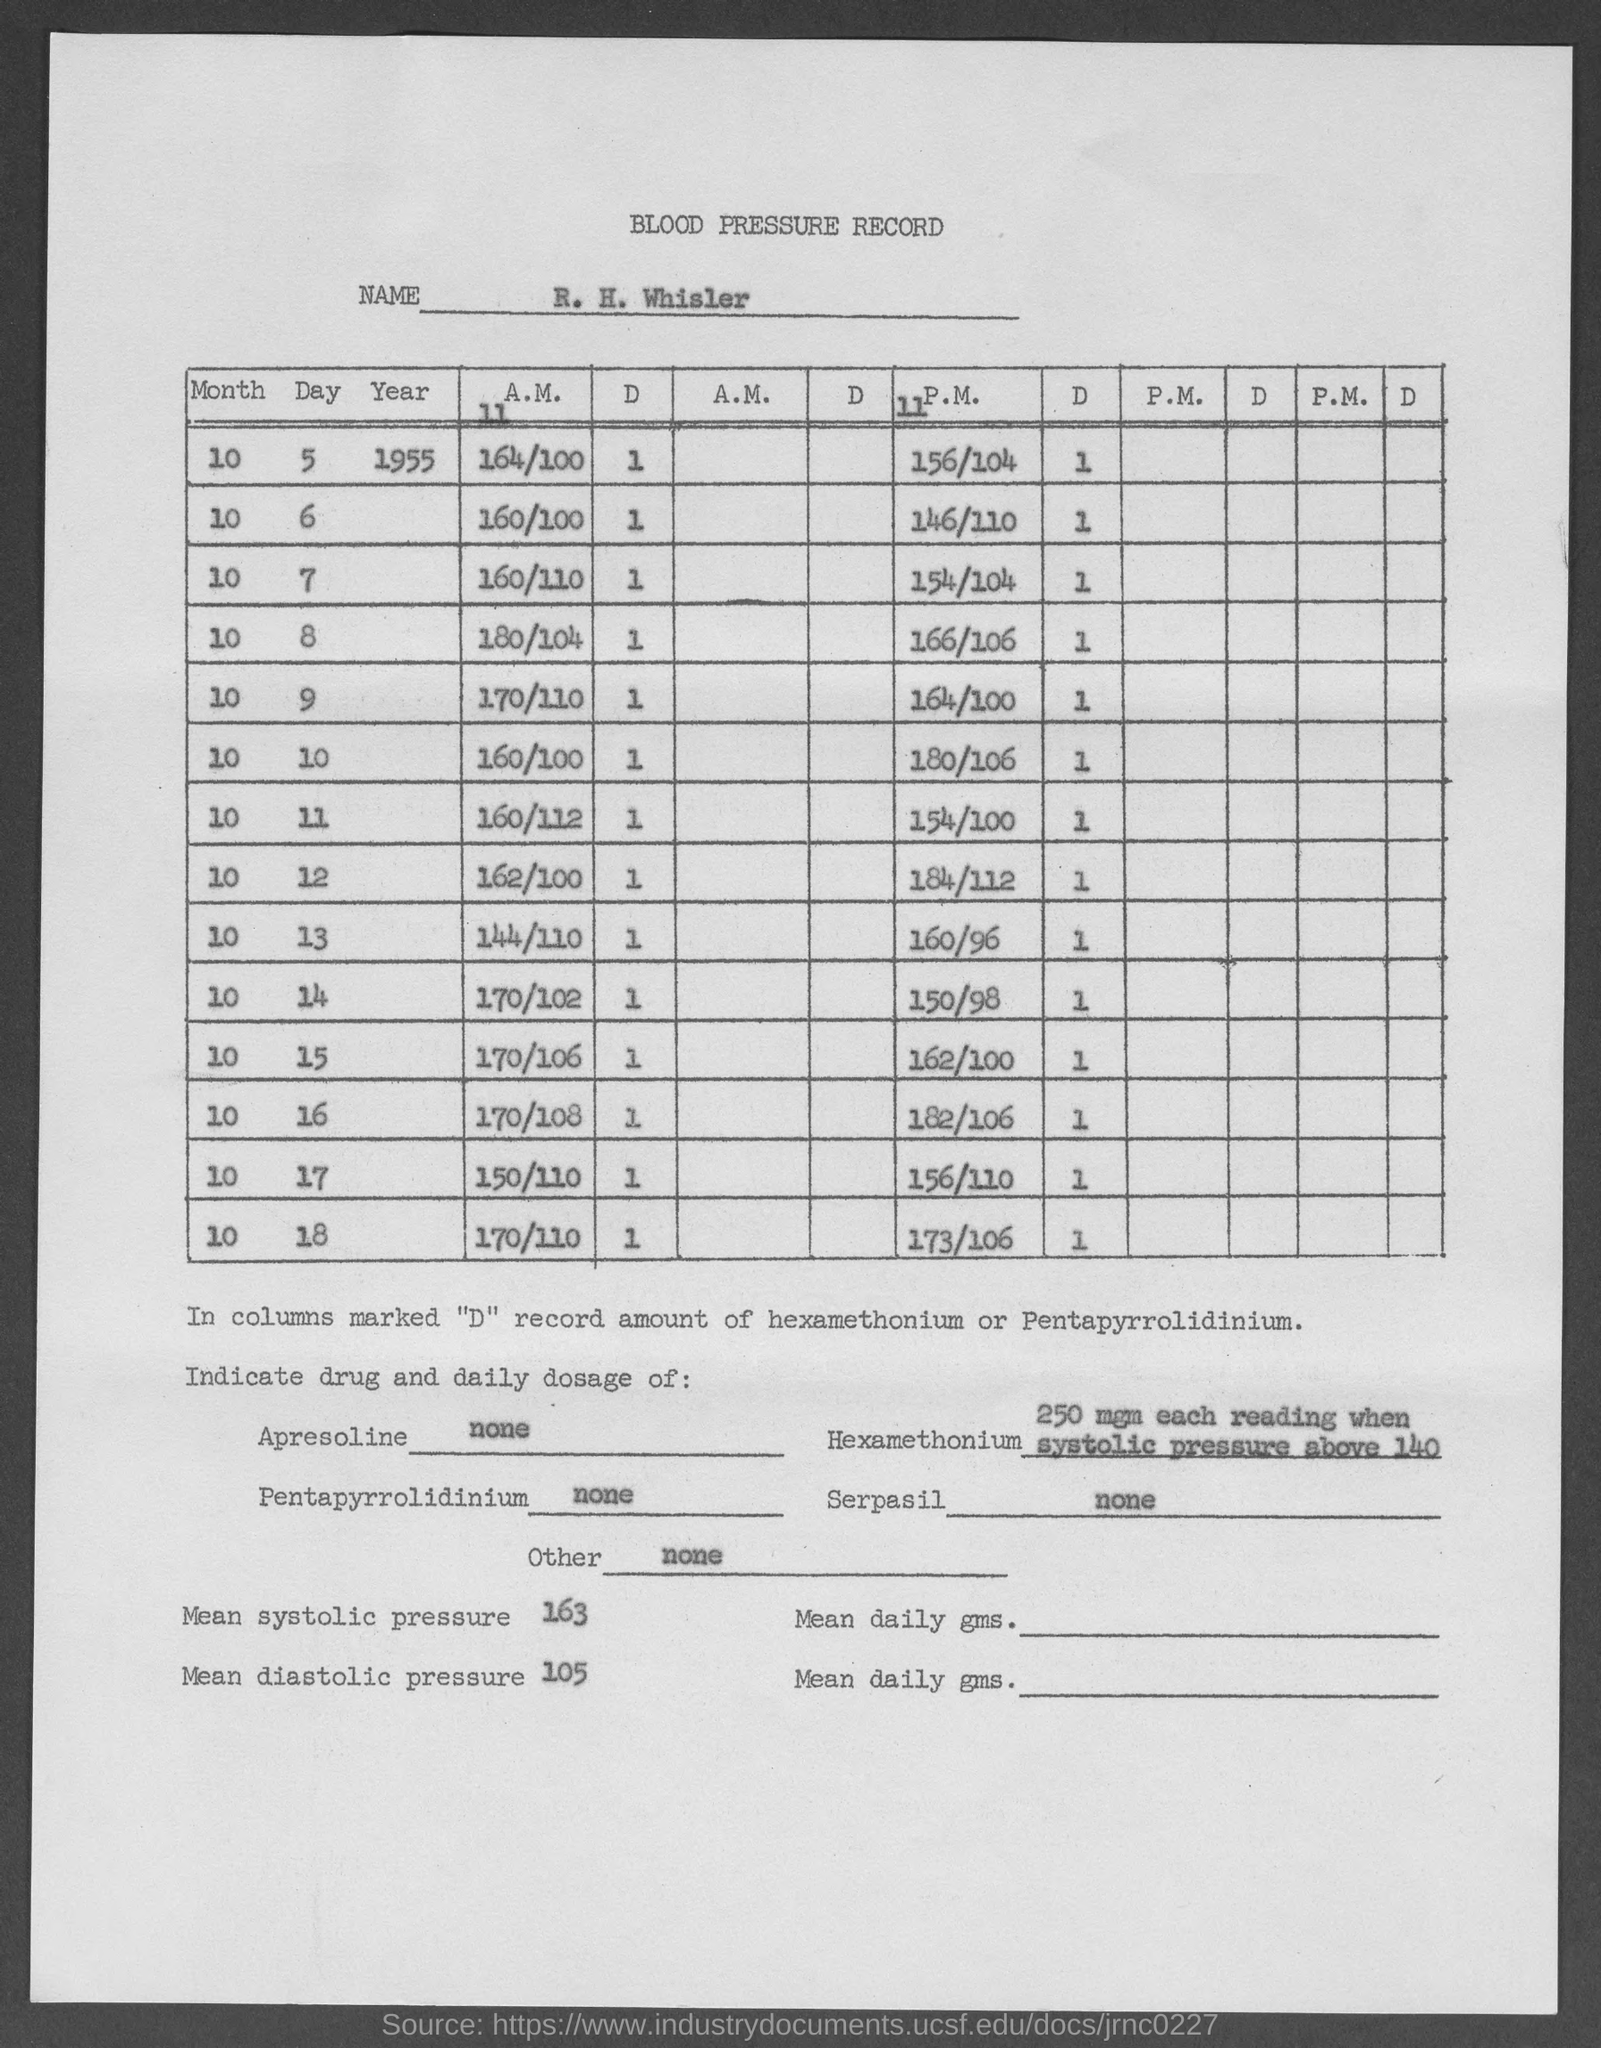What is the value of mean systolic pressure mentioned in the given record ?
Provide a succinct answer. 163. What is the value of mean diastolic pressure mentioned in the given record ?
Your answer should be compact. 105. 